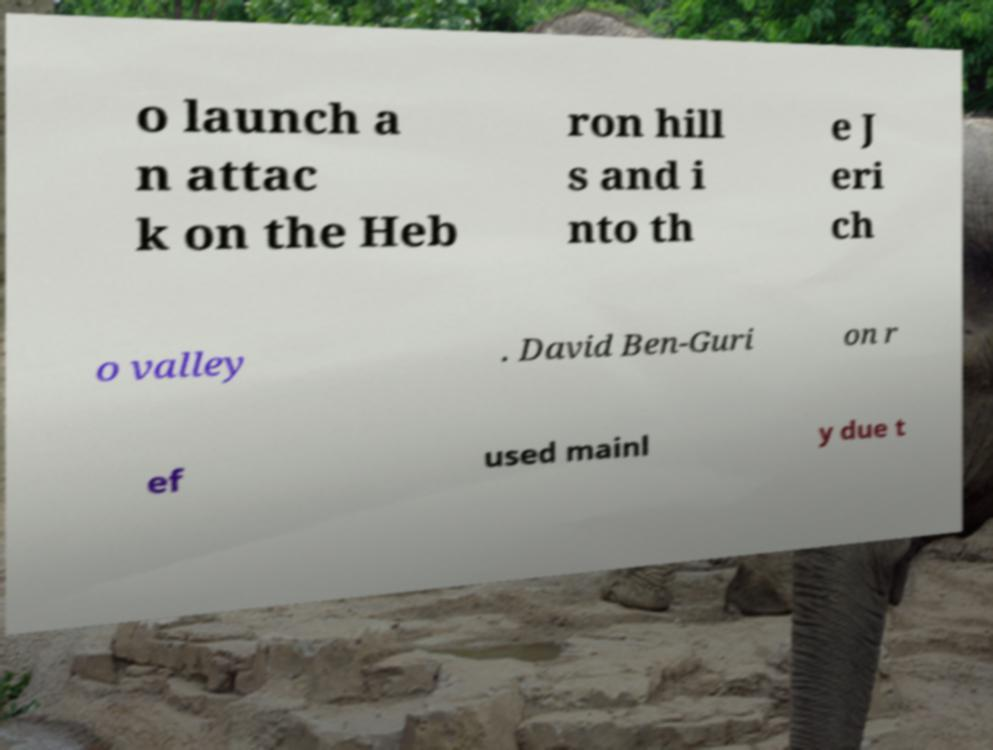I need the written content from this picture converted into text. Can you do that? o launch a n attac k on the Heb ron hill s and i nto th e J eri ch o valley . David Ben-Guri on r ef used mainl y due t 